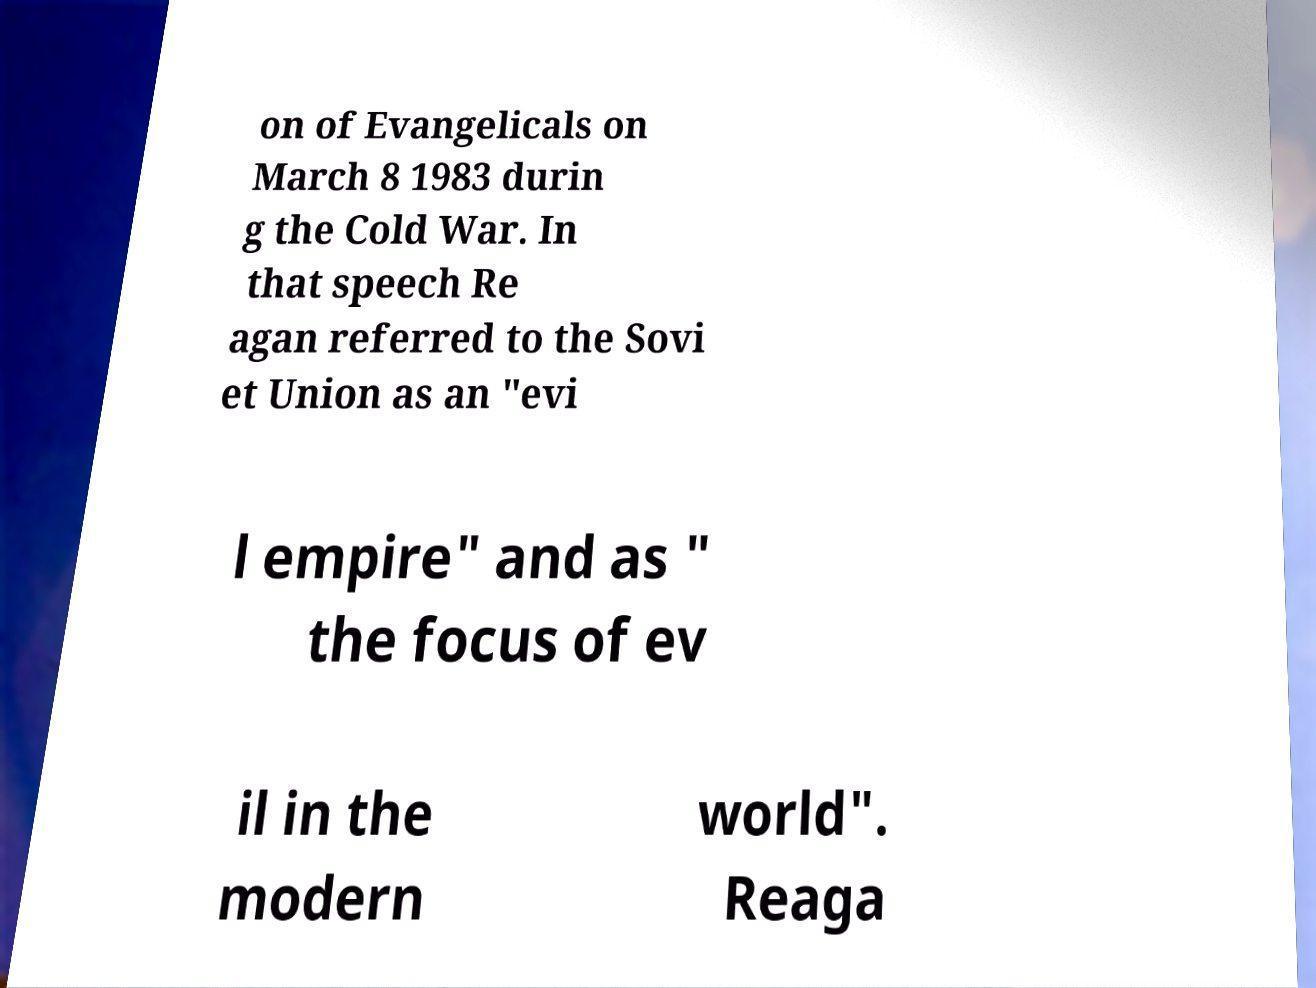Can you read and provide the text displayed in the image?This photo seems to have some interesting text. Can you extract and type it out for me? on of Evangelicals on March 8 1983 durin g the Cold War. In that speech Re agan referred to the Sovi et Union as an "evi l empire" and as " the focus of ev il in the modern world". Reaga 